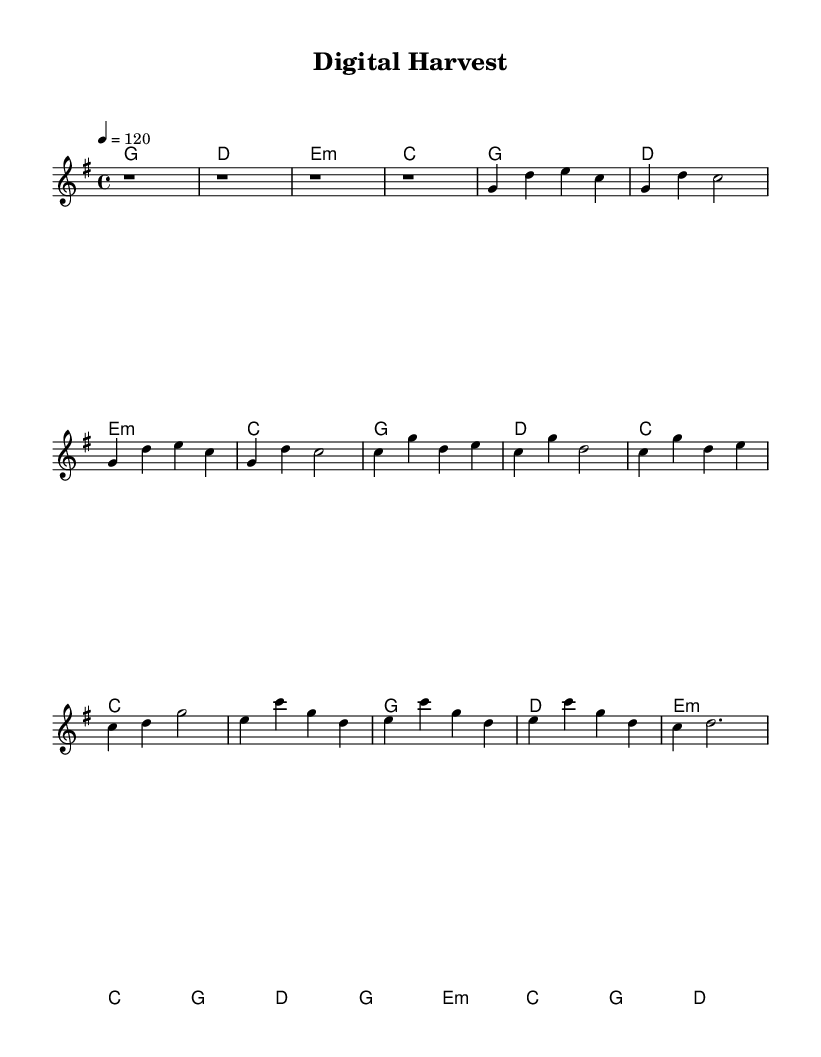What is the key signature of this music? The key signature is G major, which has one sharp (F#).
Answer: G major What is the time signature of the music? The time signature shown in the score is 4/4, indicating four beats in each measure.
Answer: 4/4 What is the tempo marking of the piece? The tempo marking indicates a speed of 120 beats per minute, as indicated by the number before the equal sign.
Answer: 120 How many measures are in the verse section? The verse section consists of four measures, as indicated by the repeated sequence of notes and rhythms.
Answer: 4 What chord follows the chorus section? The last chord of the chorus section is the G major chord, appearing before the bridge begins.
Answer: G What types of harmonies are used in this piece? The piece features major, minor, and C major chords, showcasing a blend of harmonic varieties found in country rock.
Answer: Major, minor, C major Which musical form does this piece primarily use? The form of the piece is verse-chorus-verse, common in country rock, reflecting a typical song structure.
Answer: Verse-chorus-verse 